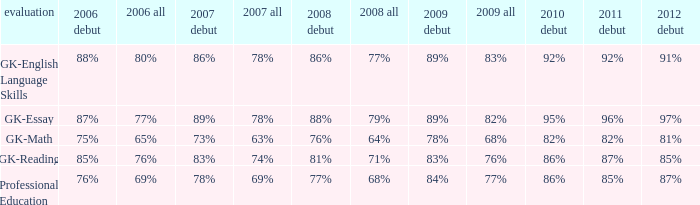What is the percentage for all 2008 when all in 2007 is 69%? 68%. 